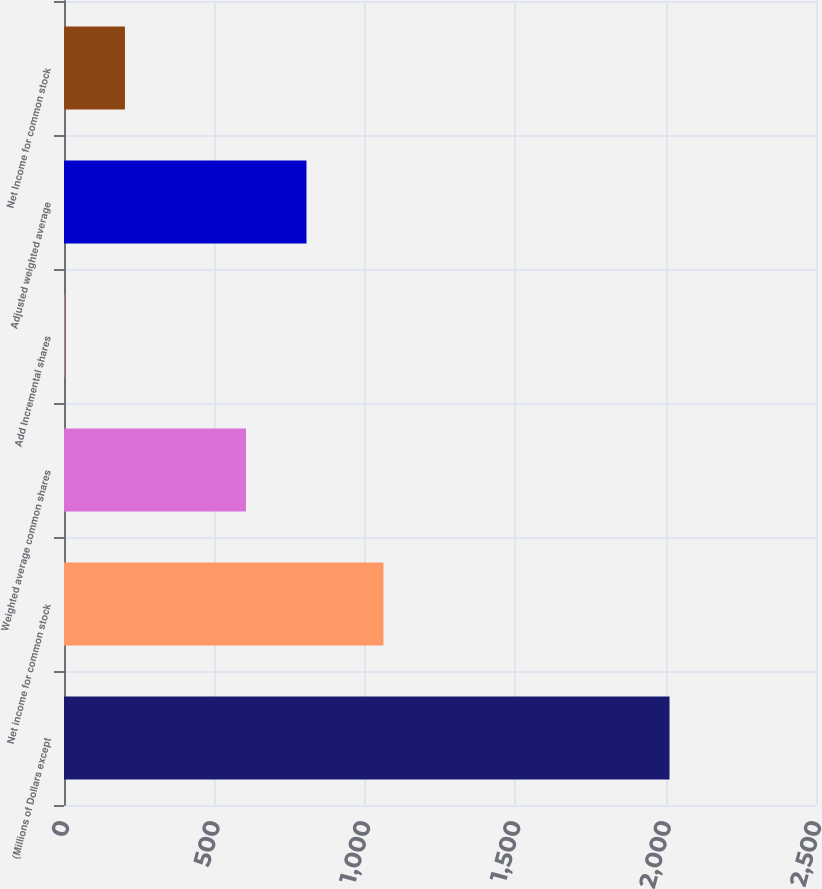Convert chart. <chart><loc_0><loc_0><loc_500><loc_500><bar_chart><fcel>(Millions of Dollars except<fcel>Net income for common stock<fcel>Weighted average common shares<fcel>Add Incremental shares<fcel>Adjusted weighted average<fcel>Net Income for common stock<nl><fcel>2013<fcel>1062<fcel>604.95<fcel>1.5<fcel>806.1<fcel>202.65<nl></chart> 